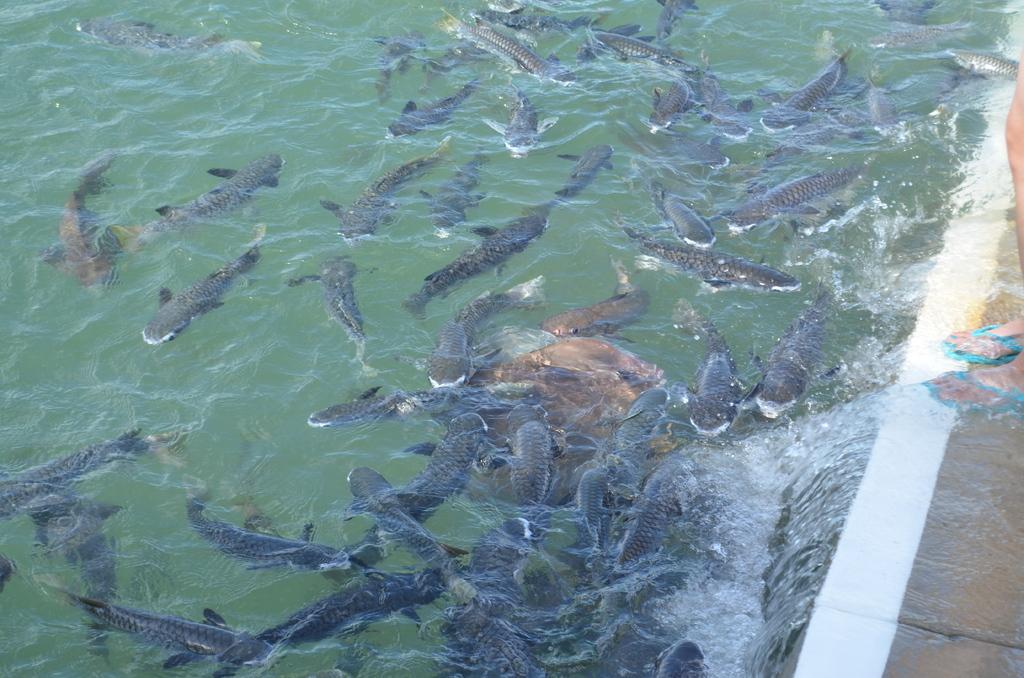Please provide a concise description of this image. In the image there are many sharks in the water, on the right side there is a person standing on the wall. 